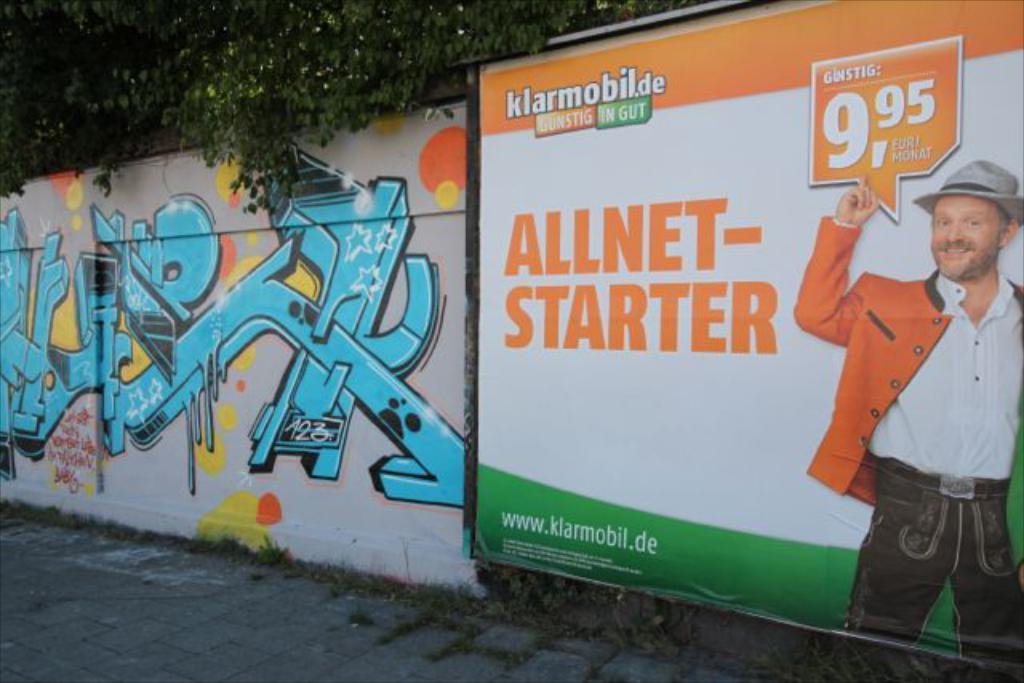<image>
Give a short and clear explanation of the subsequent image. an advertisement for klarmobil's allnet starter at 9.95 